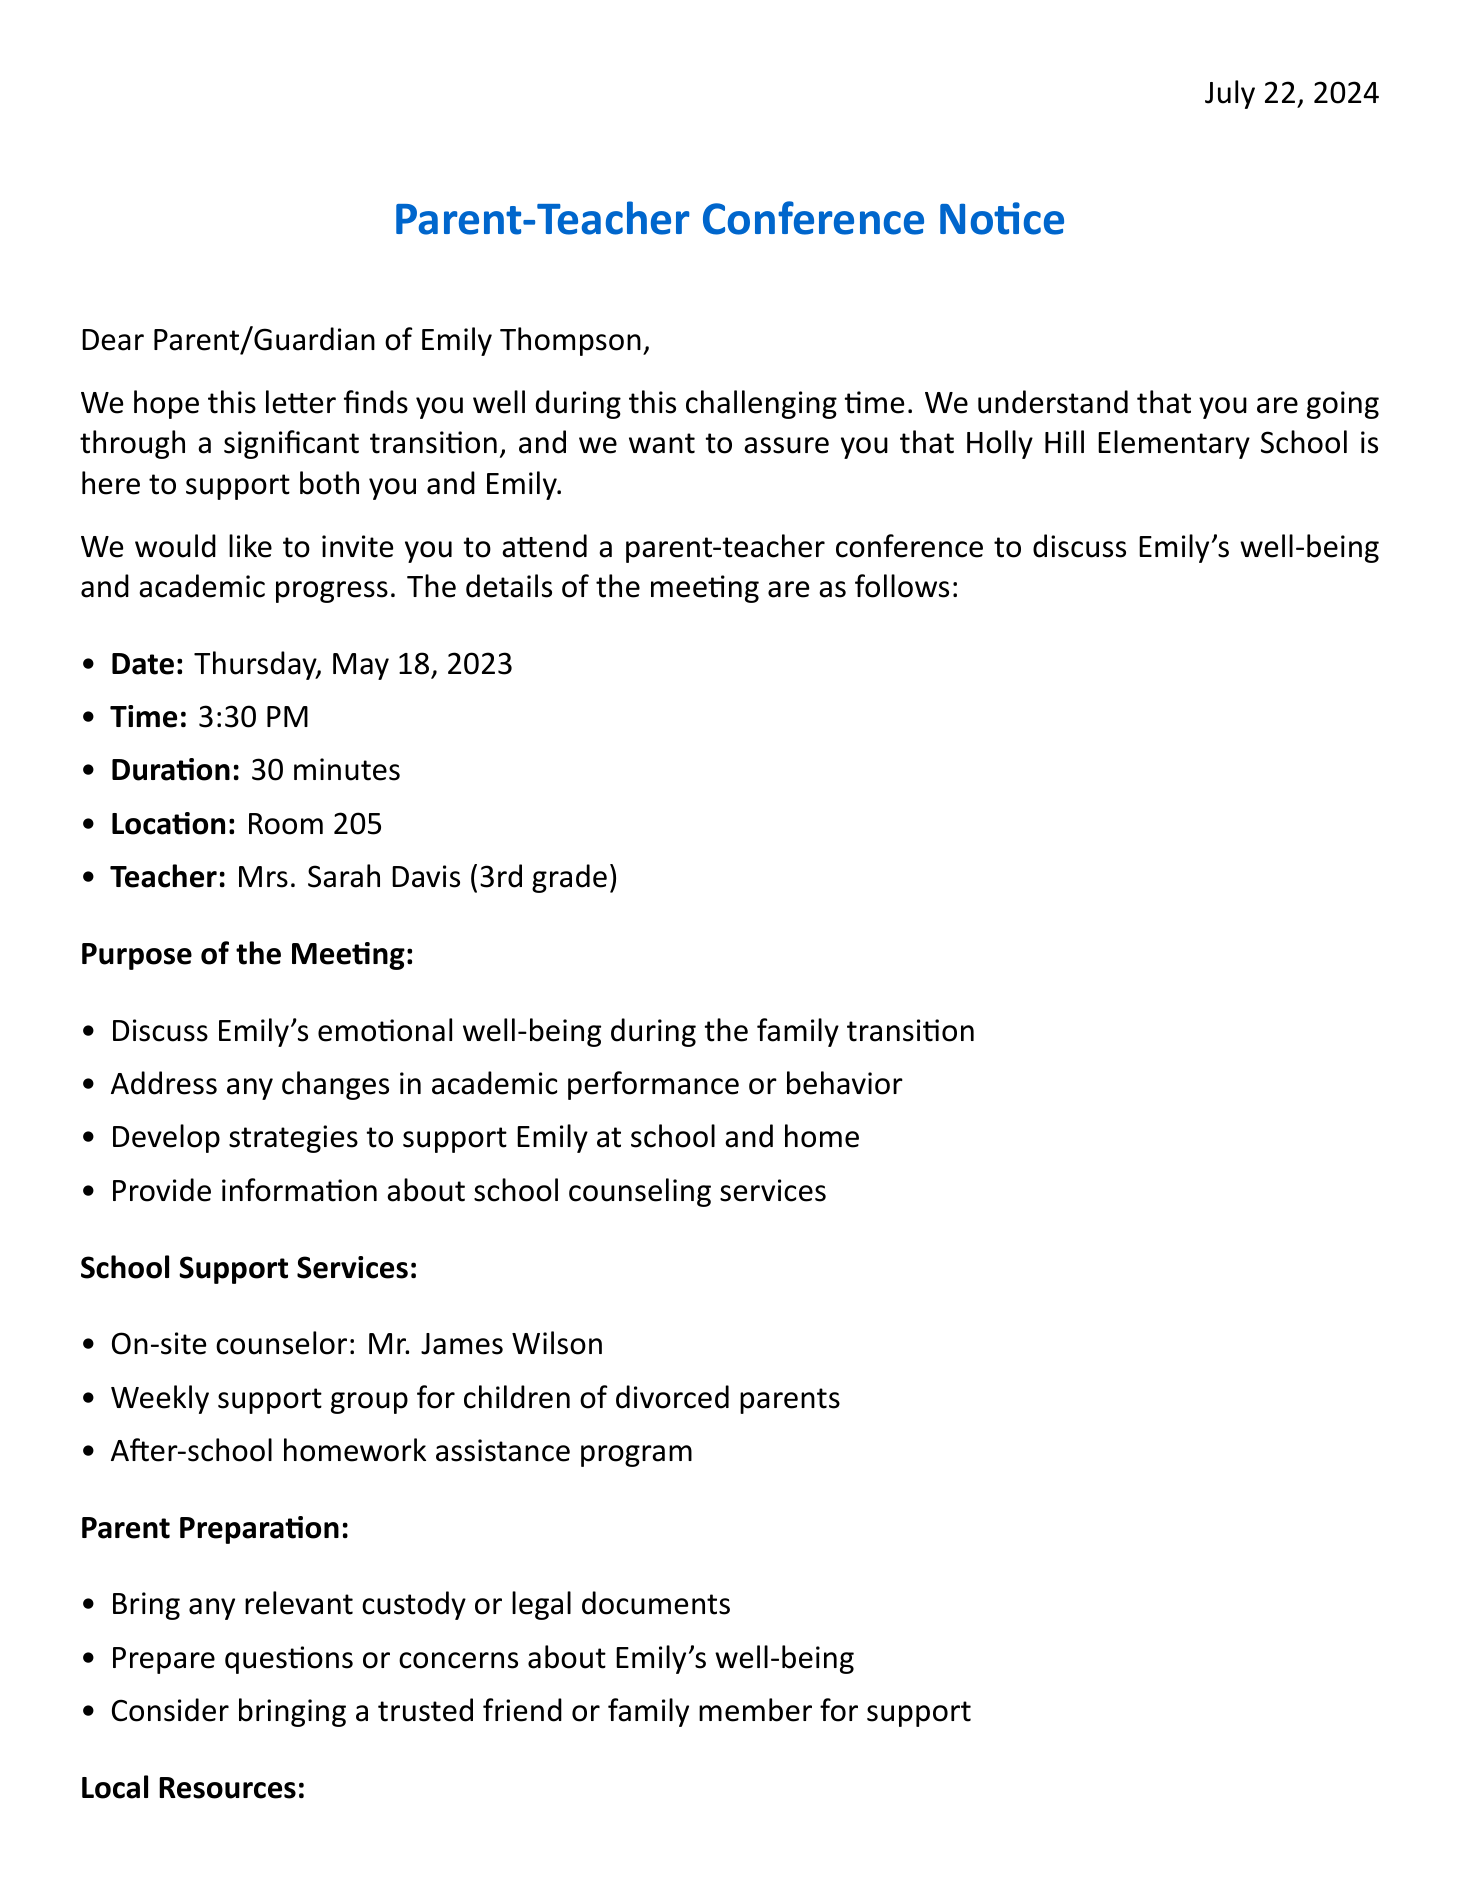What is the name of the school? The document provides information about Holly Hill Elementary School, which is the name of the school.
Answer: Holly Hill Elementary School Who is the principal? According to the document, the principal of the school is Dr. Melissa Johnson.
Answer: Dr. Melissa Johnson What date is the conference scheduled? The document specifies that the conference is scheduled for Thursday, May 18, 2023.
Answer: Thursday, May 18, 2023 What time is the parent-teacher conference? The document states that the parent-teacher conference will be held at 3:30 PM.
Answer: 3:30 PM Who should be contacted for RSVP? The document mentions that Mrs. Sarah Davis should be contacted for RSVP regarding the conference.
Answer: Mrs. Sarah Davis What is one purpose of the meeting? The document lists several purposes for the meeting, including discussing Emily's emotional well-being during the family transition.
Answer: Discuss Emily's emotional well-being during the family transition What school support service is available? The document lists multiple services, one of which is the on-site counselor Mr. James Wilson.
Answer: Mr. James Wilson What is suggested for parents to bring to the meeting? The document advises parents to bring any relevant custody or legal documents to the meeting.
Answer: Relevant custody or legal documents When is the RSVP deadline? The document states that the deadline to RSVP is Monday, May 15, 2023.
Answer: Monday, May 15, 2023 